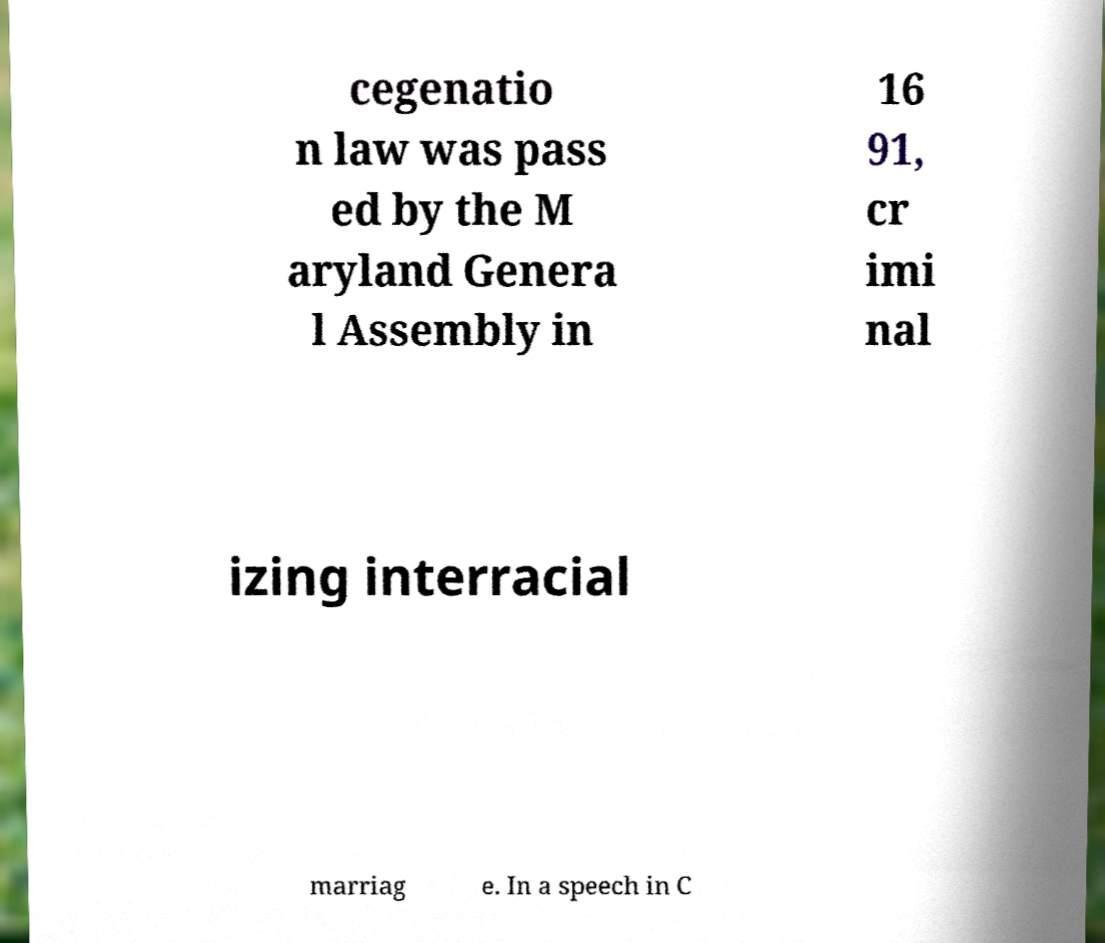What messages or text are displayed in this image? I need them in a readable, typed format. cegenatio n law was pass ed by the M aryland Genera l Assembly in 16 91, cr imi nal izing interracial marriag e. In a speech in C 